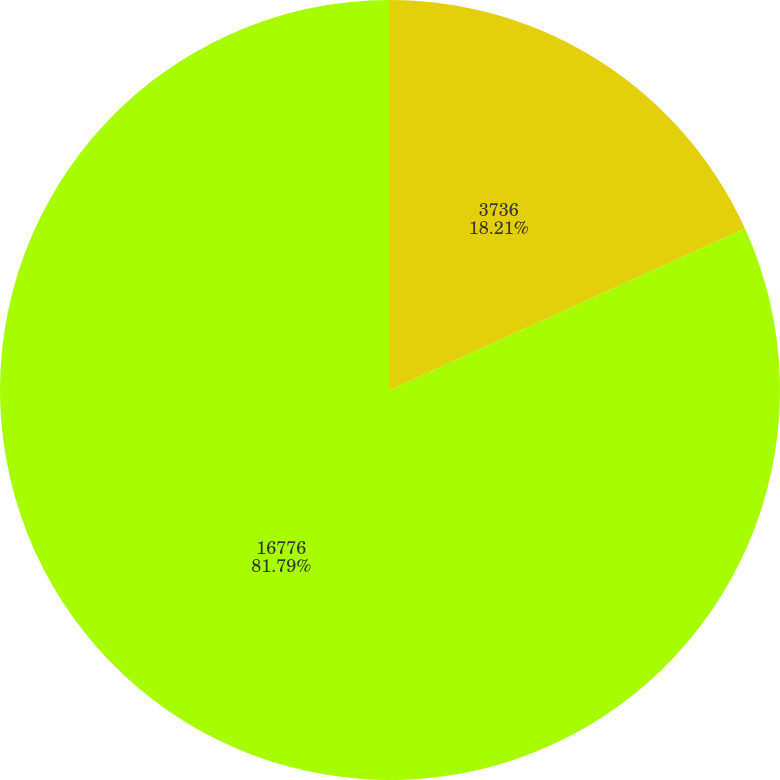Convert chart. <chart><loc_0><loc_0><loc_500><loc_500><pie_chart><fcel>3736<fcel>16776<nl><fcel>18.21%<fcel>81.79%<nl></chart> 